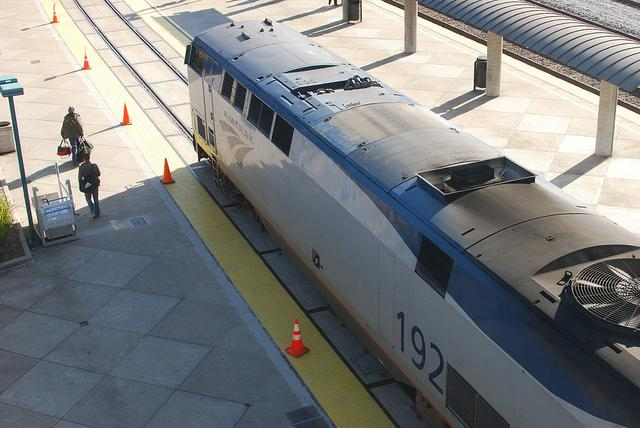What is the sum of the three digits on the train?

Choices:
A) 12
B) 82
C) four
D) 25 12 